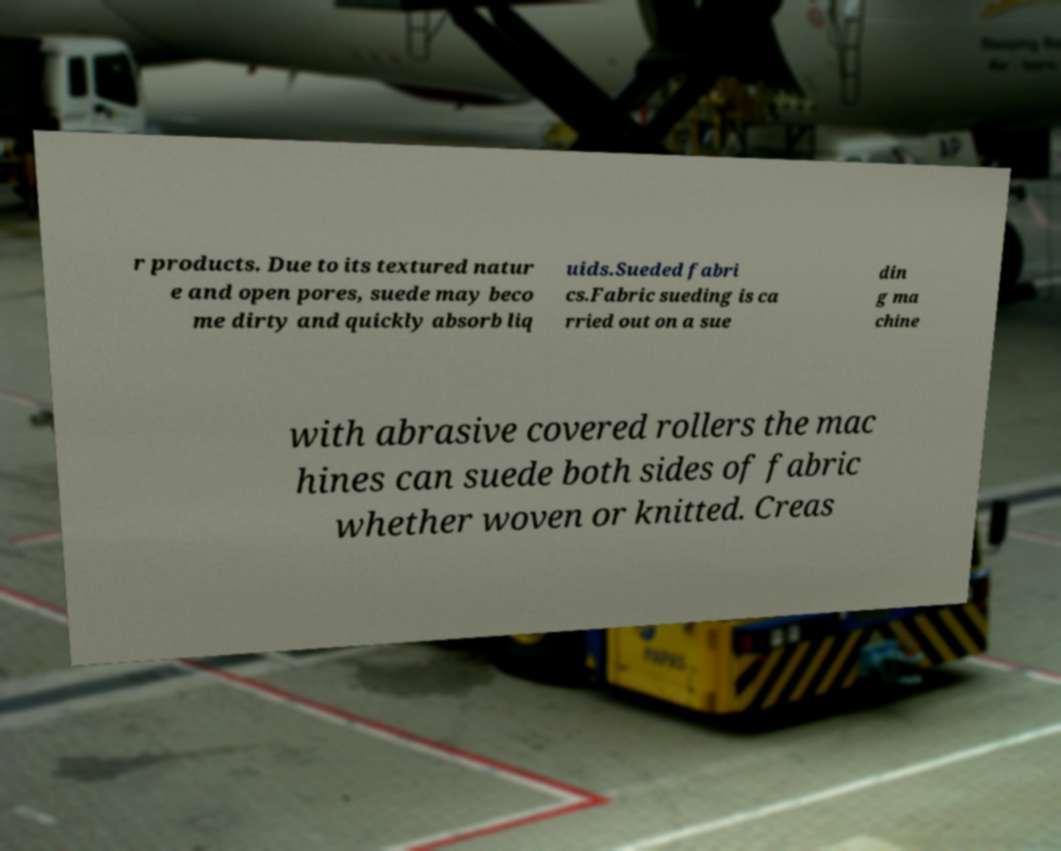Can you read and provide the text displayed in the image?This photo seems to have some interesting text. Can you extract and type it out for me? r products. Due to its textured natur e and open pores, suede may beco me dirty and quickly absorb liq uids.Sueded fabri cs.Fabric sueding is ca rried out on a sue din g ma chine with abrasive covered rollers the mac hines can suede both sides of fabric whether woven or knitted. Creas 